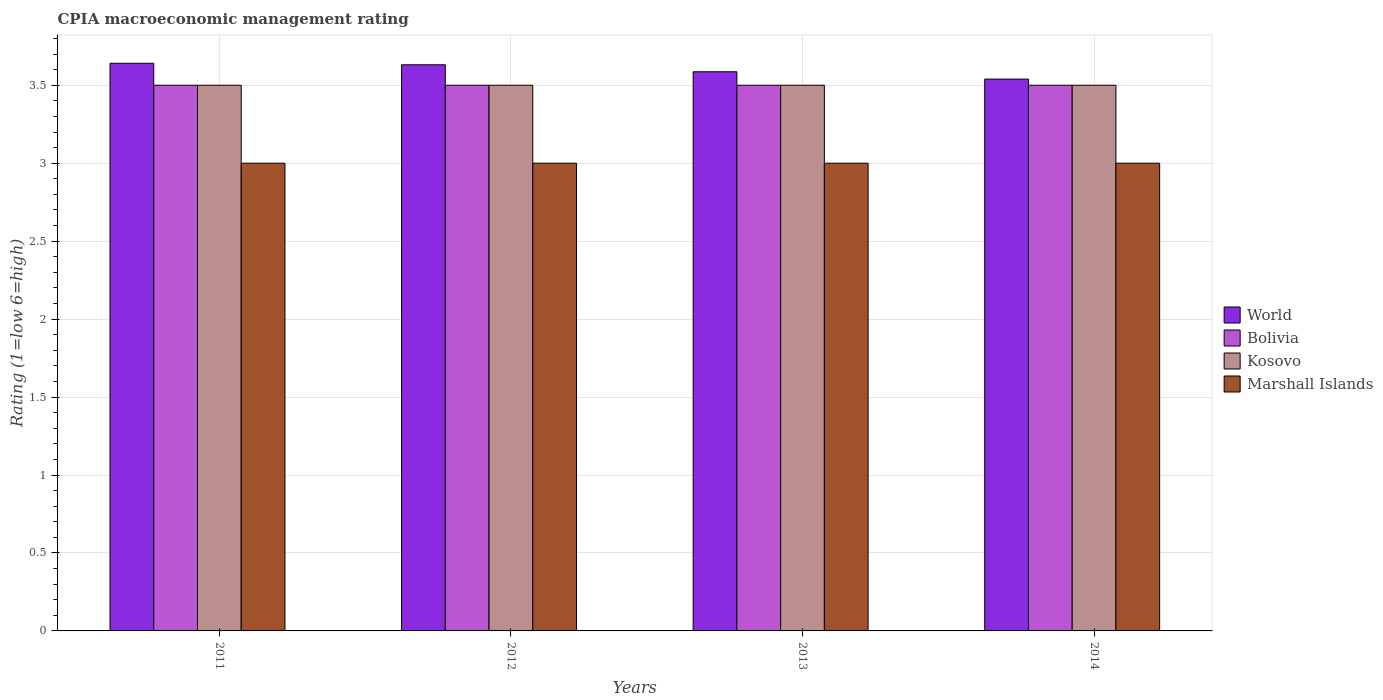How many different coloured bars are there?
Ensure brevity in your answer.  4. How many groups of bars are there?
Offer a very short reply. 4. Are the number of bars per tick equal to the number of legend labels?
Give a very brief answer. Yes. Are the number of bars on each tick of the X-axis equal?
Your answer should be very brief. Yes. What is the label of the 2nd group of bars from the left?
Provide a succinct answer. 2012. In how many cases, is the number of bars for a given year not equal to the number of legend labels?
Offer a very short reply. 0. What is the CPIA rating in Bolivia in 2014?
Provide a succinct answer. 3.5. Across all years, what is the maximum CPIA rating in World?
Keep it short and to the point. 3.64. Across all years, what is the minimum CPIA rating in Marshall Islands?
Give a very brief answer. 3. What is the total CPIA rating in Kosovo in the graph?
Your answer should be compact. 14. What is the difference between the CPIA rating in Kosovo in 2012 and the CPIA rating in World in 2013?
Make the answer very short. -0.09. What is the average CPIA rating in World per year?
Give a very brief answer. 3.6. In how many years, is the CPIA rating in Kosovo greater than 3.7?
Ensure brevity in your answer.  0. What is the difference between the highest and the second highest CPIA rating in Kosovo?
Keep it short and to the point. 0. Is the sum of the CPIA rating in World in 2012 and 2014 greater than the maximum CPIA rating in Kosovo across all years?
Your answer should be very brief. Yes. What does the 2nd bar from the left in 2012 represents?
Your response must be concise. Bolivia. What does the 2nd bar from the right in 2014 represents?
Your answer should be very brief. Kosovo. Is it the case that in every year, the sum of the CPIA rating in Marshall Islands and CPIA rating in Bolivia is greater than the CPIA rating in World?
Give a very brief answer. Yes. How many bars are there?
Offer a terse response. 16. Are the values on the major ticks of Y-axis written in scientific E-notation?
Offer a very short reply. No. Does the graph contain any zero values?
Your answer should be very brief. No. What is the title of the graph?
Your answer should be very brief. CPIA macroeconomic management rating. What is the label or title of the X-axis?
Your response must be concise. Years. What is the label or title of the Y-axis?
Ensure brevity in your answer.  Rating (1=low 6=high). What is the Rating (1=low 6=high) of World in 2011?
Ensure brevity in your answer.  3.64. What is the Rating (1=low 6=high) in Bolivia in 2011?
Make the answer very short. 3.5. What is the Rating (1=low 6=high) of World in 2012?
Offer a terse response. 3.63. What is the Rating (1=low 6=high) of Bolivia in 2012?
Your response must be concise. 3.5. What is the Rating (1=low 6=high) of Kosovo in 2012?
Offer a very short reply. 3.5. What is the Rating (1=low 6=high) of Marshall Islands in 2012?
Keep it short and to the point. 3. What is the Rating (1=low 6=high) of World in 2013?
Ensure brevity in your answer.  3.59. What is the Rating (1=low 6=high) in Bolivia in 2013?
Offer a very short reply. 3.5. What is the Rating (1=low 6=high) in Kosovo in 2013?
Your answer should be compact. 3.5. What is the Rating (1=low 6=high) of Marshall Islands in 2013?
Offer a very short reply. 3. What is the Rating (1=low 6=high) in World in 2014?
Give a very brief answer. 3.54. What is the Rating (1=low 6=high) of Kosovo in 2014?
Your response must be concise. 3.5. What is the Rating (1=low 6=high) of Marshall Islands in 2014?
Offer a very short reply. 3. Across all years, what is the maximum Rating (1=low 6=high) of World?
Make the answer very short. 3.64. Across all years, what is the maximum Rating (1=low 6=high) in Bolivia?
Make the answer very short. 3.5. Across all years, what is the maximum Rating (1=low 6=high) in Kosovo?
Give a very brief answer. 3.5. Across all years, what is the minimum Rating (1=low 6=high) in World?
Offer a terse response. 3.54. Across all years, what is the minimum Rating (1=low 6=high) of Bolivia?
Make the answer very short. 3.5. What is the total Rating (1=low 6=high) of World in the graph?
Your response must be concise. 14.4. What is the total Rating (1=low 6=high) of Bolivia in the graph?
Provide a short and direct response. 14. What is the total Rating (1=low 6=high) in Marshall Islands in the graph?
Provide a succinct answer. 12. What is the difference between the Rating (1=low 6=high) of World in 2011 and that in 2012?
Offer a very short reply. 0.01. What is the difference between the Rating (1=low 6=high) in Kosovo in 2011 and that in 2012?
Offer a very short reply. 0. What is the difference between the Rating (1=low 6=high) of World in 2011 and that in 2013?
Give a very brief answer. 0.05. What is the difference between the Rating (1=low 6=high) in Kosovo in 2011 and that in 2013?
Your response must be concise. 0. What is the difference between the Rating (1=low 6=high) of Marshall Islands in 2011 and that in 2013?
Your response must be concise. 0. What is the difference between the Rating (1=low 6=high) in World in 2011 and that in 2014?
Make the answer very short. 0.1. What is the difference between the Rating (1=low 6=high) in Bolivia in 2011 and that in 2014?
Offer a very short reply. 0. What is the difference between the Rating (1=low 6=high) in Kosovo in 2011 and that in 2014?
Offer a terse response. 0. What is the difference between the Rating (1=low 6=high) of Marshall Islands in 2011 and that in 2014?
Your answer should be very brief. 0. What is the difference between the Rating (1=low 6=high) of World in 2012 and that in 2013?
Ensure brevity in your answer.  0.04. What is the difference between the Rating (1=low 6=high) of Kosovo in 2012 and that in 2013?
Give a very brief answer. 0. What is the difference between the Rating (1=low 6=high) in World in 2012 and that in 2014?
Keep it short and to the point. 0.09. What is the difference between the Rating (1=low 6=high) in Bolivia in 2012 and that in 2014?
Keep it short and to the point. 0. What is the difference between the Rating (1=low 6=high) in World in 2013 and that in 2014?
Provide a short and direct response. 0.05. What is the difference between the Rating (1=low 6=high) of Marshall Islands in 2013 and that in 2014?
Ensure brevity in your answer.  0. What is the difference between the Rating (1=low 6=high) in World in 2011 and the Rating (1=low 6=high) in Bolivia in 2012?
Keep it short and to the point. 0.14. What is the difference between the Rating (1=low 6=high) of World in 2011 and the Rating (1=low 6=high) of Kosovo in 2012?
Give a very brief answer. 0.14. What is the difference between the Rating (1=low 6=high) of World in 2011 and the Rating (1=low 6=high) of Marshall Islands in 2012?
Your response must be concise. 0.64. What is the difference between the Rating (1=low 6=high) in Bolivia in 2011 and the Rating (1=low 6=high) in Marshall Islands in 2012?
Offer a terse response. 0.5. What is the difference between the Rating (1=low 6=high) in World in 2011 and the Rating (1=low 6=high) in Bolivia in 2013?
Keep it short and to the point. 0.14. What is the difference between the Rating (1=low 6=high) of World in 2011 and the Rating (1=low 6=high) of Kosovo in 2013?
Keep it short and to the point. 0.14. What is the difference between the Rating (1=low 6=high) in World in 2011 and the Rating (1=low 6=high) in Marshall Islands in 2013?
Your answer should be compact. 0.64. What is the difference between the Rating (1=low 6=high) of World in 2011 and the Rating (1=low 6=high) of Bolivia in 2014?
Your answer should be very brief. 0.14. What is the difference between the Rating (1=low 6=high) of World in 2011 and the Rating (1=low 6=high) of Kosovo in 2014?
Offer a terse response. 0.14. What is the difference between the Rating (1=low 6=high) of World in 2011 and the Rating (1=low 6=high) of Marshall Islands in 2014?
Offer a terse response. 0.64. What is the difference between the Rating (1=low 6=high) in Bolivia in 2011 and the Rating (1=low 6=high) in Marshall Islands in 2014?
Offer a terse response. 0.5. What is the difference between the Rating (1=low 6=high) in World in 2012 and the Rating (1=low 6=high) in Bolivia in 2013?
Give a very brief answer. 0.13. What is the difference between the Rating (1=low 6=high) in World in 2012 and the Rating (1=low 6=high) in Kosovo in 2013?
Keep it short and to the point. 0.13. What is the difference between the Rating (1=low 6=high) of World in 2012 and the Rating (1=low 6=high) of Marshall Islands in 2013?
Offer a terse response. 0.63. What is the difference between the Rating (1=low 6=high) of Bolivia in 2012 and the Rating (1=low 6=high) of Kosovo in 2013?
Make the answer very short. 0. What is the difference between the Rating (1=low 6=high) in World in 2012 and the Rating (1=low 6=high) in Bolivia in 2014?
Your answer should be compact. 0.13. What is the difference between the Rating (1=low 6=high) of World in 2012 and the Rating (1=low 6=high) of Kosovo in 2014?
Offer a very short reply. 0.13. What is the difference between the Rating (1=low 6=high) in World in 2012 and the Rating (1=low 6=high) in Marshall Islands in 2014?
Keep it short and to the point. 0.63. What is the difference between the Rating (1=low 6=high) of Bolivia in 2012 and the Rating (1=low 6=high) of Kosovo in 2014?
Provide a short and direct response. 0. What is the difference between the Rating (1=low 6=high) in World in 2013 and the Rating (1=low 6=high) in Bolivia in 2014?
Provide a succinct answer. 0.09. What is the difference between the Rating (1=low 6=high) in World in 2013 and the Rating (1=low 6=high) in Kosovo in 2014?
Offer a very short reply. 0.09. What is the difference between the Rating (1=low 6=high) in World in 2013 and the Rating (1=low 6=high) in Marshall Islands in 2014?
Ensure brevity in your answer.  0.59. What is the difference between the Rating (1=low 6=high) of Bolivia in 2013 and the Rating (1=low 6=high) of Kosovo in 2014?
Make the answer very short. 0. What is the difference between the Rating (1=low 6=high) of Bolivia in 2013 and the Rating (1=low 6=high) of Marshall Islands in 2014?
Your answer should be compact. 0.5. What is the difference between the Rating (1=low 6=high) of Kosovo in 2013 and the Rating (1=low 6=high) of Marshall Islands in 2014?
Offer a terse response. 0.5. What is the average Rating (1=low 6=high) of World per year?
Ensure brevity in your answer.  3.6. What is the average Rating (1=low 6=high) of Bolivia per year?
Your response must be concise. 3.5. What is the average Rating (1=low 6=high) of Marshall Islands per year?
Offer a terse response. 3. In the year 2011, what is the difference between the Rating (1=low 6=high) of World and Rating (1=low 6=high) of Bolivia?
Make the answer very short. 0.14. In the year 2011, what is the difference between the Rating (1=low 6=high) in World and Rating (1=low 6=high) in Kosovo?
Provide a succinct answer. 0.14. In the year 2011, what is the difference between the Rating (1=low 6=high) in World and Rating (1=low 6=high) in Marshall Islands?
Give a very brief answer. 0.64. In the year 2011, what is the difference between the Rating (1=low 6=high) in Bolivia and Rating (1=low 6=high) in Marshall Islands?
Offer a terse response. 0.5. In the year 2012, what is the difference between the Rating (1=low 6=high) in World and Rating (1=low 6=high) in Bolivia?
Your response must be concise. 0.13. In the year 2012, what is the difference between the Rating (1=low 6=high) in World and Rating (1=low 6=high) in Kosovo?
Offer a terse response. 0.13. In the year 2012, what is the difference between the Rating (1=low 6=high) in World and Rating (1=low 6=high) in Marshall Islands?
Give a very brief answer. 0.63. In the year 2013, what is the difference between the Rating (1=low 6=high) of World and Rating (1=low 6=high) of Bolivia?
Ensure brevity in your answer.  0.09. In the year 2013, what is the difference between the Rating (1=low 6=high) of World and Rating (1=low 6=high) of Kosovo?
Keep it short and to the point. 0.09. In the year 2013, what is the difference between the Rating (1=low 6=high) in World and Rating (1=low 6=high) in Marshall Islands?
Give a very brief answer. 0.59. In the year 2013, what is the difference between the Rating (1=low 6=high) in Bolivia and Rating (1=low 6=high) in Kosovo?
Provide a short and direct response. 0. In the year 2013, what is the difference between the Rating (1=low 6=high) of Bolivia and Rating (1=low 6=high) of Marshall Islands?
Ensure brevity in your answer.  0.5. In the year 2014, what is the difference between the Rating (1=low 6=high) of World and Rating (1=low 6=high) of Bolivia?
Provide a short and direct response. 0.04. In the year 2014, what is the difference between the Rating (1=low 6=high) of World and Rating (1=low 6=high) of Kosovo?
Your answer should be compact. 0.04. In the year 2014, what is the difference between the Rating (1=low 6=high) of World and Rating (1=low 6=high) of Marshall Islands?
Your answer should be very brief. 0.54. In the year 2014, what is the difference between the Rating (1=low 6=high) of Kosovo and Rating (1=low 6=high) of Marshall Islands?
Offer a very short reply. 0.5. What is the ratio of the Rating (1=low 6=high) in World in 2011 to that in 2012?
Ensure brevity in your answer.  1. What is the ratio of the Rating (1=low 6=high) of Bolivia in 2011 to that in 2012?
Give a very brief answer. 1. What is the ratio of the Rating (1=low 6=high) in Kosovo in 2011 to that in 2012?
Give a very brief answer. 1. What is the ratio of the Rating (1=low 6=high) in Marshall Islands in 2011 to that in 2012?
Provide a succinct answer. 1. What is the ratio of the Rating (1=low 6=high) in World in 2011 to that in 2013?
Ensure brevity in your answer.  1.02. What is the ratio of the Rating (1=low 6=high) in Bolivia in 2011 to that in 2013?
Keep it short and to the point. 1. What is the ratio of the Rating (1=low 6=high) of Kosovo in 2011 to that in 2013?
Your answer should be compact. 1. What is the ratio of the Rating (1=low 6=high) in Marshall Islands in 2011 to that in 2013?
Offer a terse response. 1. What is the ratio of the Rating (1=low 6=high) in World in 2011 to that in 2014?
Your answer should be very brief. 1.03. What is the ratio of the Rating (1=low 6=high) in World in 2012 to that in 2013?
Ensure brevity in your answer.  1.01. What is the ratio of the Rating (1=low 6=high) of Bolivia in 2012 to that in 2013?
Your answer should be very brief. 1. What is the ratio of the Rating (1=low 6=high) in Kosovo in 2012 to that in 2013?
Provide a short and direct response. 1. What is the ratio of the Rating (1=low 6=high) of World in 2012 to that in 2014?
Your answer should be compact. 1.03. What is the ratio of the Rating (1=low 6=high) of World in 2013 to that in 2014?
Offer a very short reply. 1.01. What is the ratio of the Rating (1=low 6=high) of Bolivia in 2013 to that in 2014?
Ensure brevity in your answer.  1. What is the difference between the highest and the second highest Rating (1=low 6=high) of World?
Ensure brevity in your answer.  0.01. What is the difference between the highest and the second highest Rating (1=low 6=high) in Marshall Islands?
Provide a short and direct response. 0. What is the difference between the highest and the lowest Rating (1=low 6=high) of World?
Provide a short and direct response. 0.1. What is the difference between the highest and the lowest Rating (1=low 6=high) in Kosovo?
Your answer should be compact. 0. What is the difference between the highest and the lowest Rating (1=low 6=high) in Marshall Islands?
Offer a terse response. 0. 